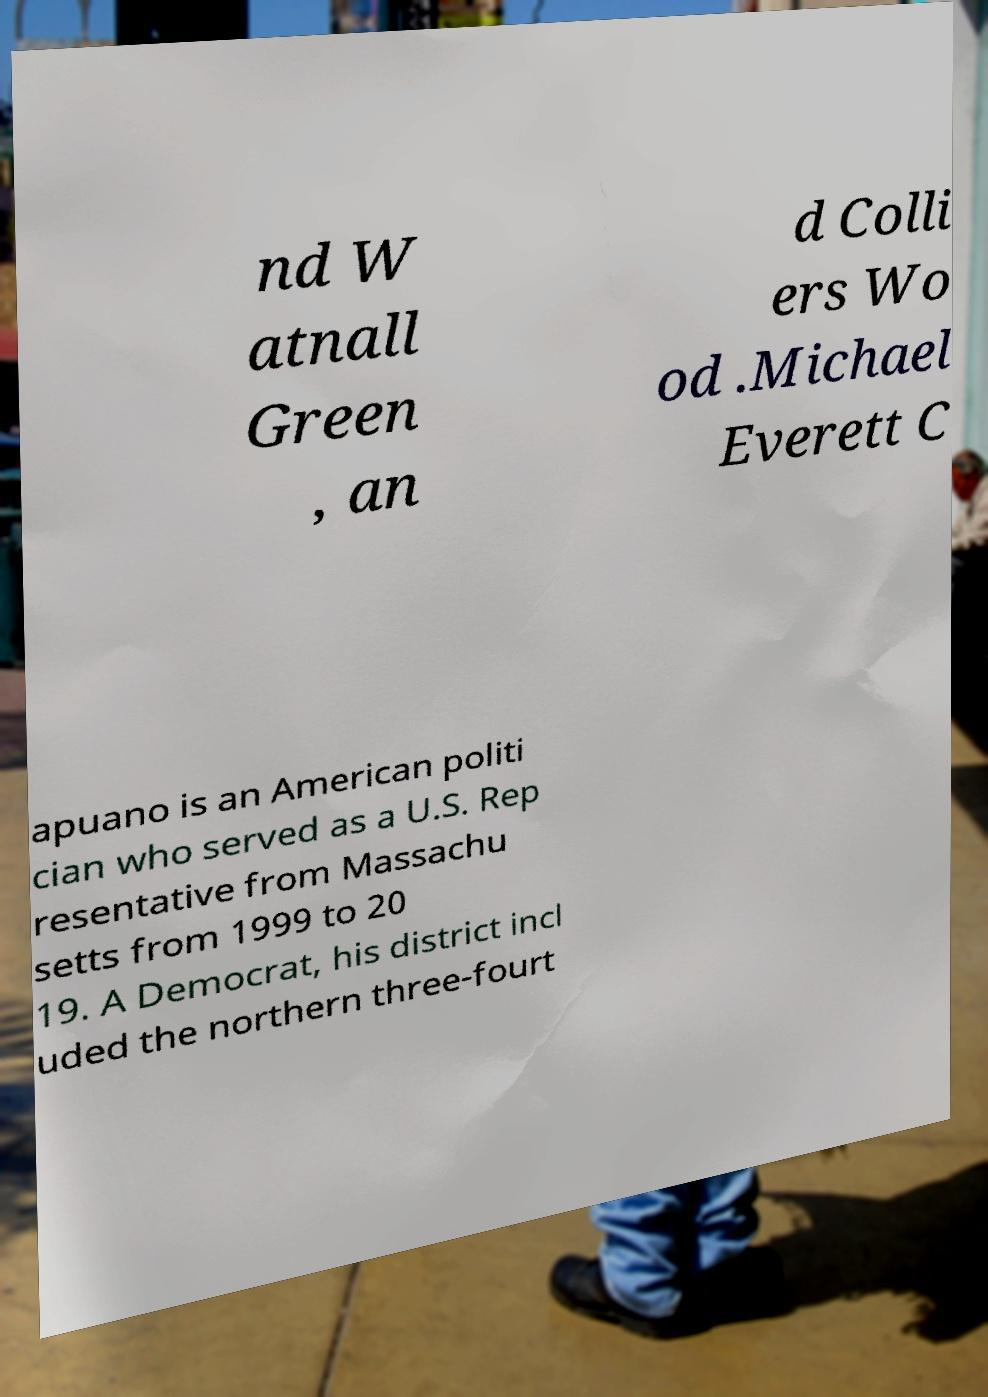Please identify and transcribe the text found in this image. nd W atnall Green , an d Colli ers Wo od .Michael Everett C apuano is an American politi cian who served as a U.S. Rep resentative from Massachu setts from 1999 to 20 19. A Democrat, his district incl uded the northern three-fourt 